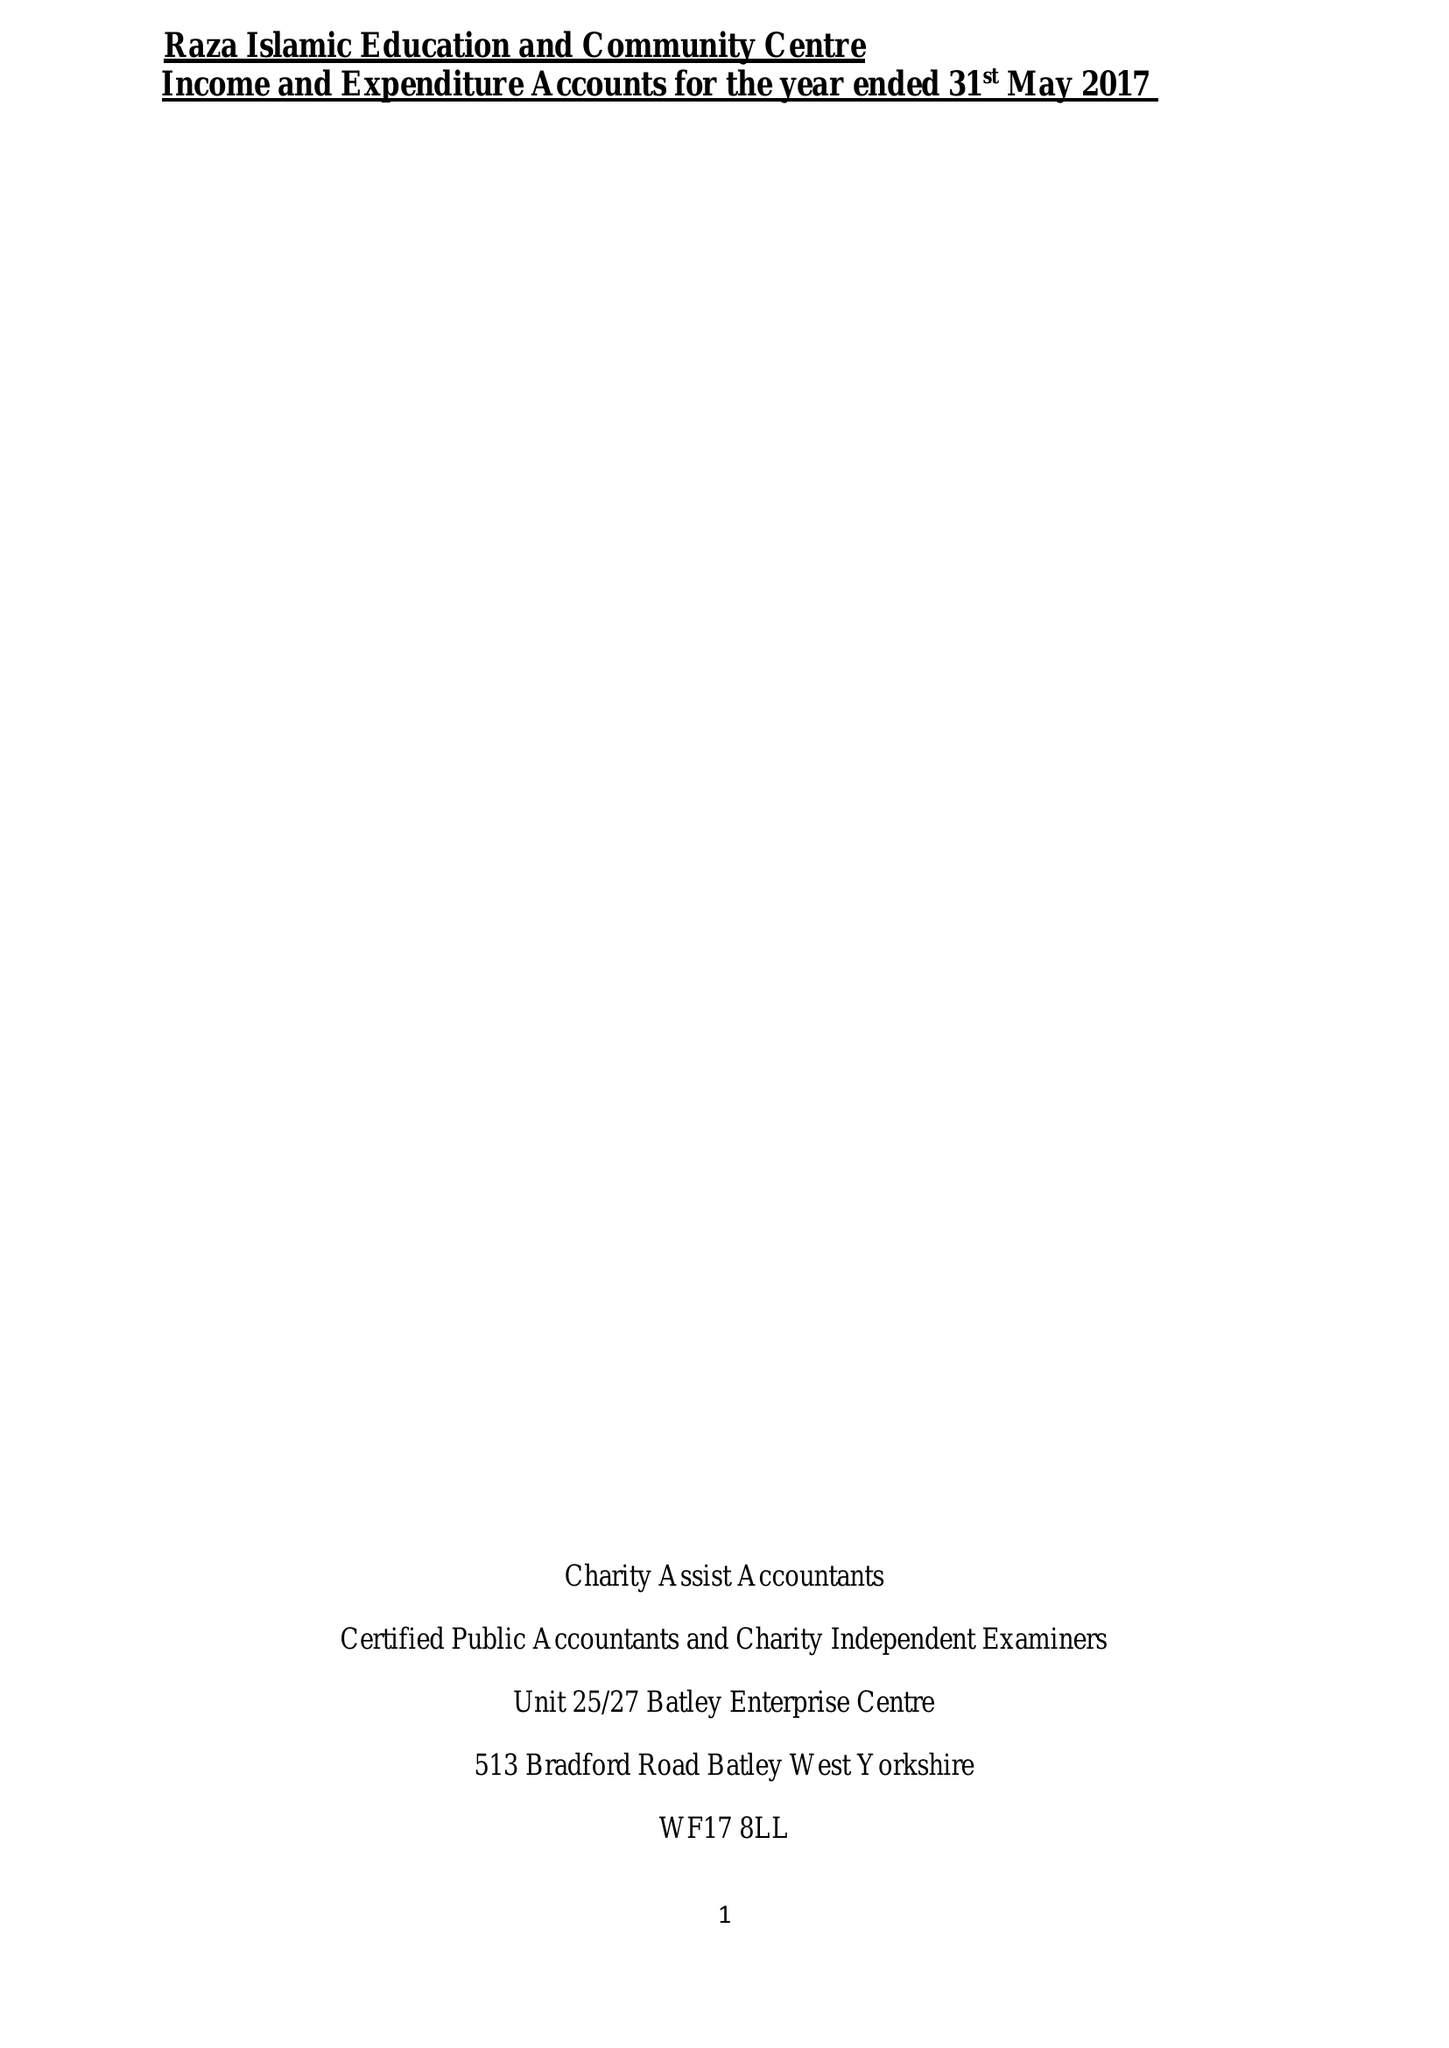What is the value for the income_annually_in_british_pounds?
Answer the question using a single word or phrase. 71575.00 